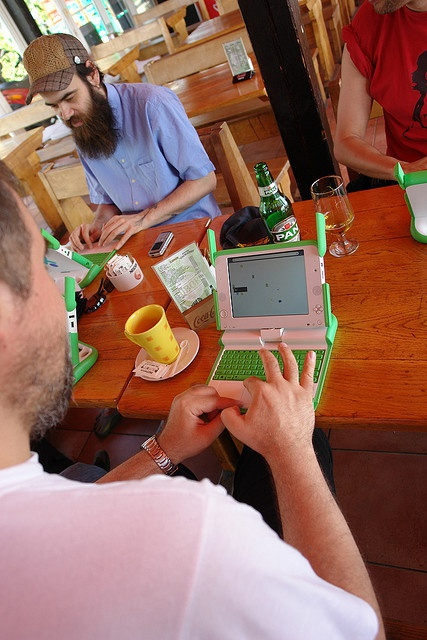Describe the objects in this image and their specific colors. I can see people in darkgray, lightpink, lavender, brown, and pink tones, dining table in darkgray, brown, maroon, and red tones, people in darkgray, brown, and gray tones, people in darkgray, maroon, brown, and black tones, and laptop in darkgray, gray, and lightpink tones in this image. 